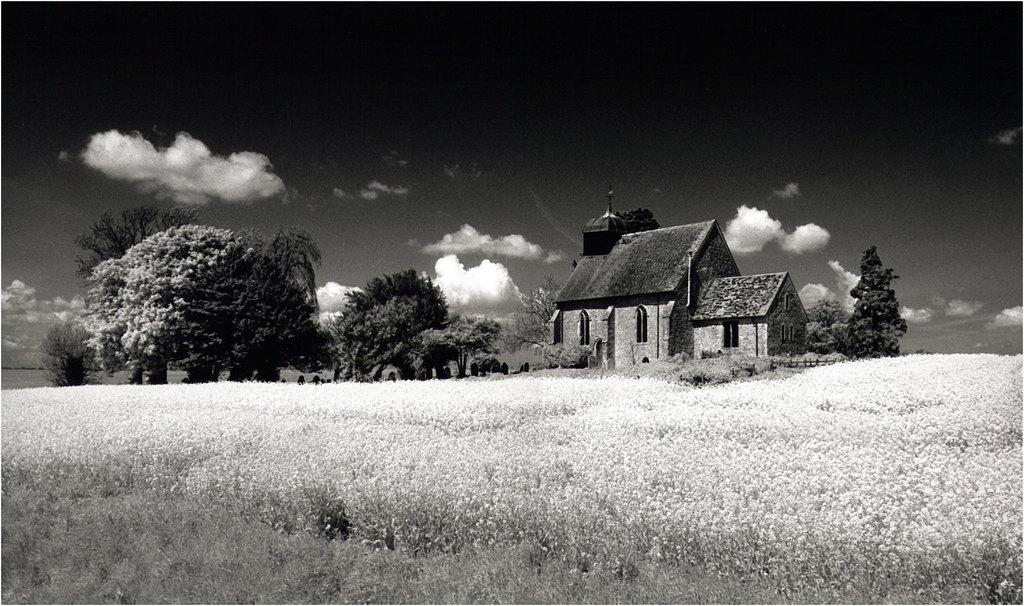What structure is located on the right side of the image? There is a building on the right side of the image. What type of vegetation can be seen in the image? There are trees, grass, and plants in the image. What is the condition of the sky in the image? The sky is clear in the image. What is the color scheme of the image? The image is black and white. What type of lace can be seen on the building in the image? There is no lace present on the building in the image, as it is a black and white photograph. What type of engine is powering the trees in the image? There is no engine present in the image, as trees are natural vegetation and do not require an engine to function. 